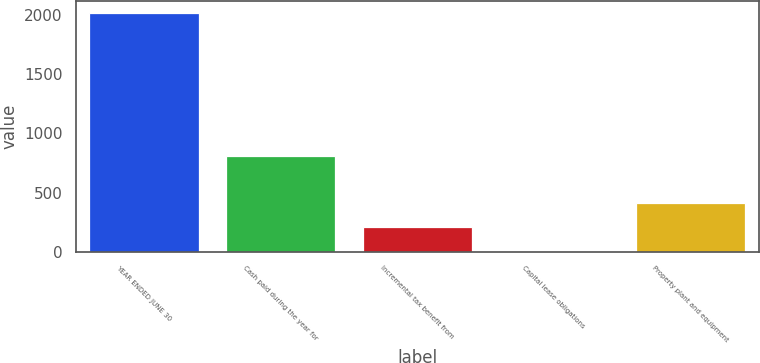<chart> <loc_0><loc_0><loc_500><loc_500><bar_chart><fcel>YEAR ENDED JUNE 30<fcel>Cash paid during the year for<fcel>Incremental tax benefit from<fcel>Capital lease obligations<fcel>Property plant and equipment<nl><fcel>2015<fcel>811.22<fcel>209.33<fcel>8.7<fcel>409.96<nl></chart> 